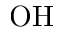Convert formula to latex. <formula><loc_0><loc_0><loc_500><loc_500>O H</formula> 